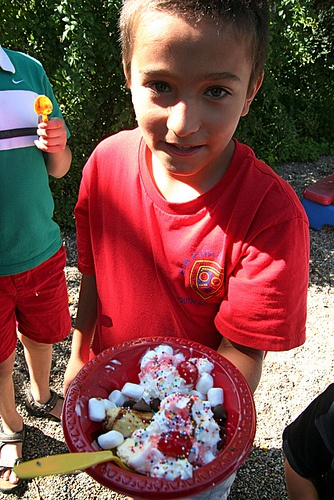Describe the objects in this image and their specific colors. I can see people in darkgreen, maroon, brown, red, and black tones, bowl in darkgreen, maroon, brown, black, and lightblue tones, people in darkgreen, teal, brown, and maroon tones, people in darkgreen, black, maroon, brown, and gray tones, and spoon in darkgreen, olive, and tan tones in this image. 